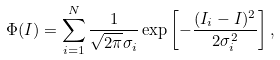Convert formula to latex. <formula><loc_0><loc_0><loc_500><loc_500>\Phi ( I ) = \sum _ { i = 1 } ^ { N } \frac { 1 } { \sqrt { 2 \pi } \sigma _ { i } } \exp \left [ - \frac { ( I _ { i } - I ) ^ { 2 } } { 2 \sigma _ { i } ^ { 2 } } \right ] ,</formula> 